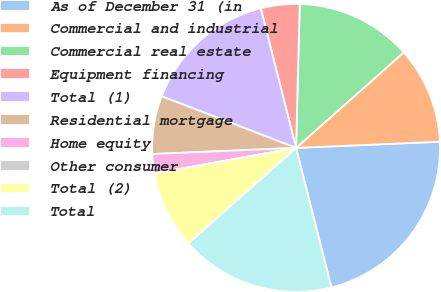<chart> <loc_0><loc_0><loc_500><loc_500><pie_chart><fcel>As of December 31 (in<fcel>Commercial and industrial<fcel>Commercial real estate<fcel>Equipment financing<fcel>Total (1)<fcel>Residential mortgage<fcel>Home equity<fcel>Other consumer<fcel>Total (2)<fcel>Total<nl><fcel>21.74%<fcel>10.87%<fcel>13.04%<fcel>4.35%<fcel>15.22%<fcel>6.52%<fcel>2.17%<fcel>0.0%<fcel>8.7%<fcel>17.39%<nl></chart> 